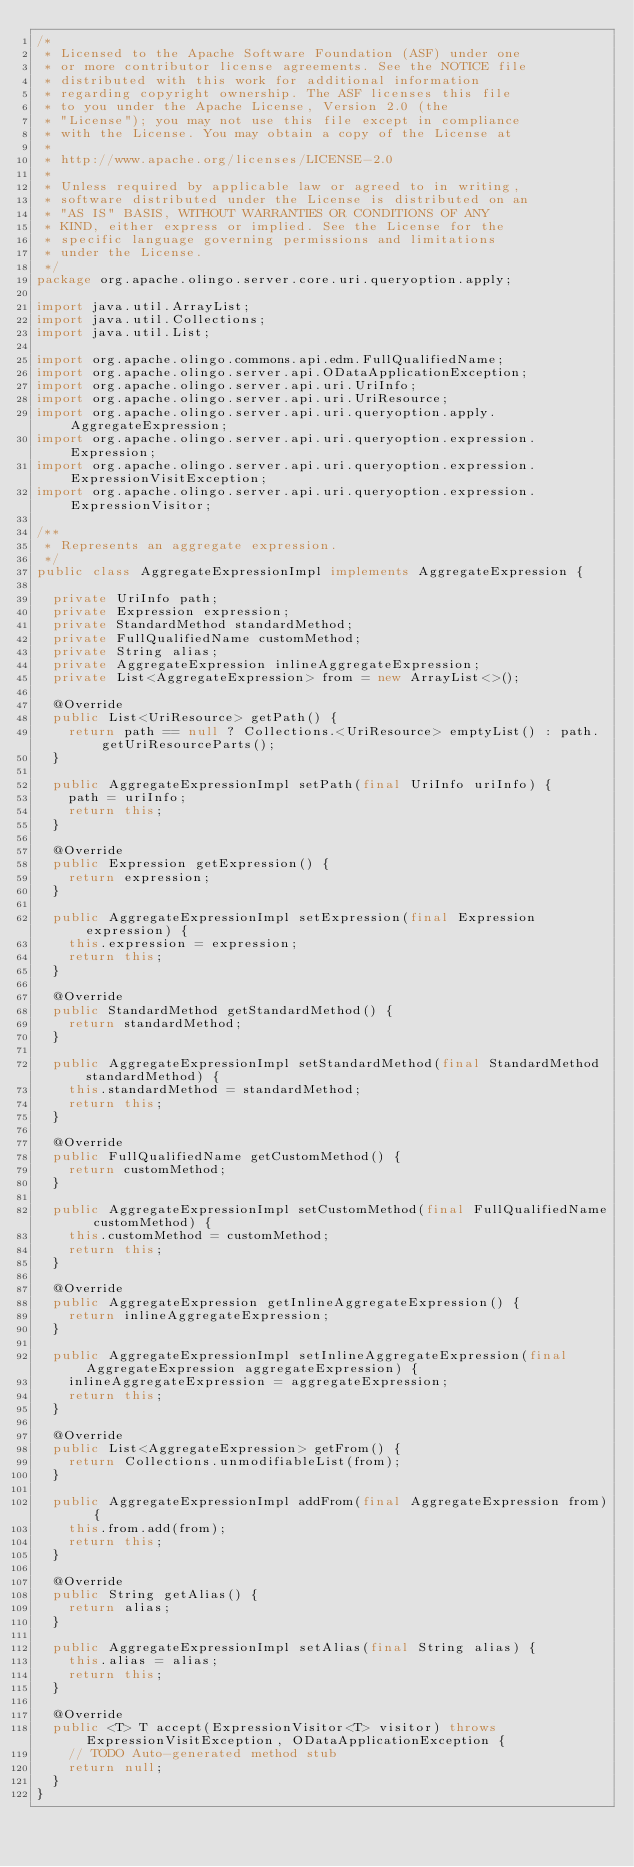Convert code to text. <code><loc_0><loc_0><loc_500><loc_500><_Java_>/*
 * Licensed to the Apache Software Foundation (ASF) under one
 * or more contributor license agreements. See the NOTICE file
 * distributed with this work for additional information
 * regarding copyright ownership. The ASF licenses this file
 * to you under the Apache License, Version 2.0 (the
 * "License"); you may not use this file except in compliance
 * with the License. You may obtain a copy of the License at
 * 
 * http://www.apache.org/licenses/LICENSE-2.0
 * 
 * Unless required by applicable law or agreed to in writing,
 * software distributed under the License is distributed on an
 * "AS IS" BASIS, WITHOUT WARRANTIES OR CONDITIONS OF ANY
 * KIND, either express or implied. See the License for the
 * specific language governing permissions and limitations
 * under the License.
 */
package org.apache.olingo.server.core.uri.queryoption.apply;

import java.util.ArrayList;
import java.util.Collections;
import java.util.List;

import org.apache.olingo.commons.api.edm.FullQualifiedName;
import org.apache.olingo.server.api.ODataApplicationException;
import org.apache.olingo.server.api.uri.UriInfo;
import org.apache.olingo.server.api.uri.UriResource;
import org.apache.olingo.server.api.uri.queryoption.apply.AggregateExpression;
import org.apache.olingo.server.api.uri.queryoption.expression.Expression;
import org.apache.olingo.server.api.uri.queryoption.expression.ExpressionVisitException;
import org.apache.olingo.server.api.uri.queryoption.expression.ExpressionVisitor;

/**
 * Represents an aggregate expression.
 */
public class AggregateExpressionImpl implements AggregateExpression {

  private UriInfo path;
  private Expression expression;
  private StandardMethod standardMethod;
  private FullQualifiedName customMethod;
  private String alias;
  private AggregateExpression inlineAggregateExpression;
  private List<AggregateExpression> from = new ArrayList<>();

  @Override
  public List<UriResource> getPath() {
    return path == null ? Collections.<UriResource> emptyList() : path.getUriResourceParts();
  }

  public AggregateExpressionImpl setPath(final UriInfo uriInfo) {
    path = uriInfo;
    return this;
  }

  @Override
  public Expression getExpression() {
    return expression;
  }

  public AggregateExpressionImpl setExpression(final Expression expression) {
    this.expression = expression;
    return this;
  }

  @Override
  public StandardMethod getStandardMethod() {
    return standardMethod;
  }

  public AggregateExpressionImpl setStandardMethod(final StandardMethod standardMethod) {
    this.standardMethod = standardMethod;
    return this;
  }

  @Override
  public FullQualifiedName getCustomMethod() {
    return customMethod;
  }

  public AggregateExpressionImpl setCustomMethod(final FullQualifiedName customMethod) {
    this.customMethod = customMethod;
    return this;
  }

  @Override
  public AggregateExpression getInlineAggregateExpression() {
    return inlineAggregateExpression;
  }

  public AggregateExpressionImpl setInlineAggregateExpression(final AggregateExpression aggregateExpression) {
    inlineAggregateExpression = aggregateExpression;
    return this;
  }

  @Override
  public List<AggregateExpression> getFrom() {
    return Collections.unmodifiableList(from);
  }

  public AggregateExpressionImpl addFrom(final AggregateExpression from) {
    this.from.add(from);
    return this;
  }

  @Override
  public String getAlias() {
    return alias;
  }

  public AggregateExpressionImpl setAlias(final String alias) {
    this.alias = alias;
    return this;
  }

  @Override
  public <T> T accept(ExpressionVisitor<T> visitor) throws ExpressionVisitException, ODataApplicationException {
    // TODO Auto-generated method stub
    return null;
  }
}
</code> 